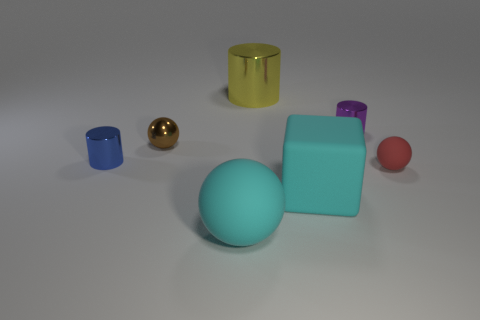Add 2 tiny blue things. How many objects exist? 9 Subtract all brown balls. How many balls are left? 2 Subtract all brown cylinders. How many blue blocks are left? 0 Subtract all tiny blue shiny cylinders. How many cylinders are left? 2 Subtract 2 cylinders. How many cylinders are left? 1 Subtract all gray spheres. Subtract all red cylinders. How many spheres are left? 3 Subtract all large gray rubber blocks. Subtract all cubes. How many objects are left? 6 Add 7 cyan rubber objects. How many cyan rubber objects are left? 9 Add 2 tiny purple rubber objects. How many tiny purple rubber objects exist? 2 Subtract 1 purple cylinders. How many objects are left? 6 